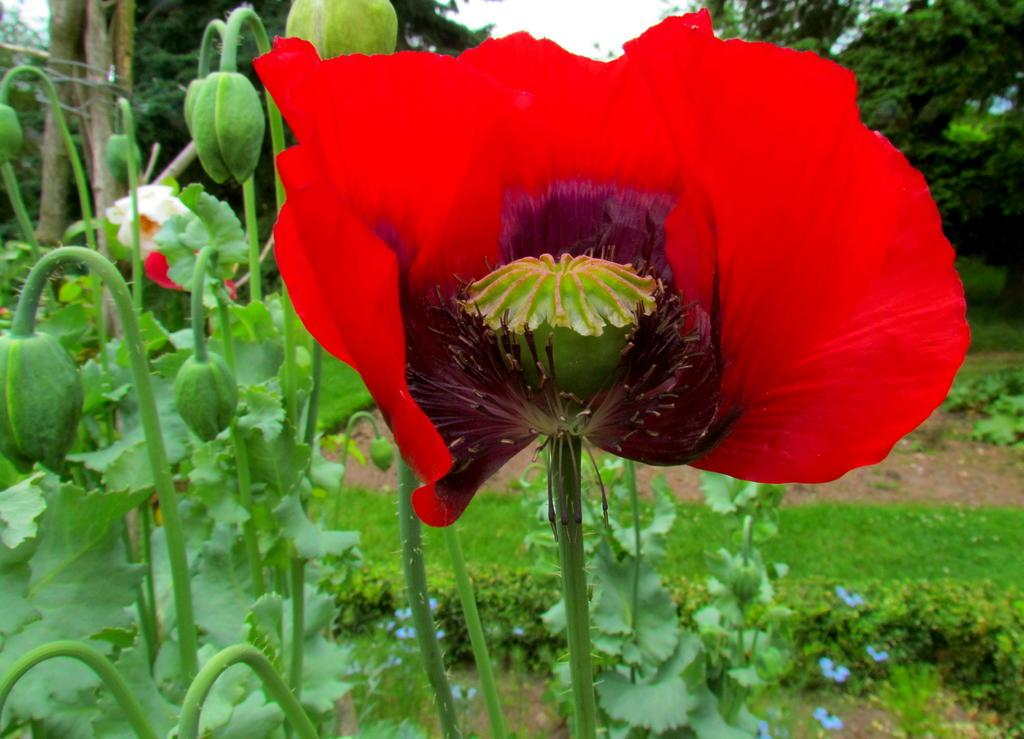What type of vegetation can be seen in the image? There are flowers, buds, trees, and grass in the image. What part of the natural environment is visible in the image? The sky is visible in the image. What type of nose can be seen on the creator in the image? There is no creator or nose present in the image; it features plants, trees, grass, and the sky. 